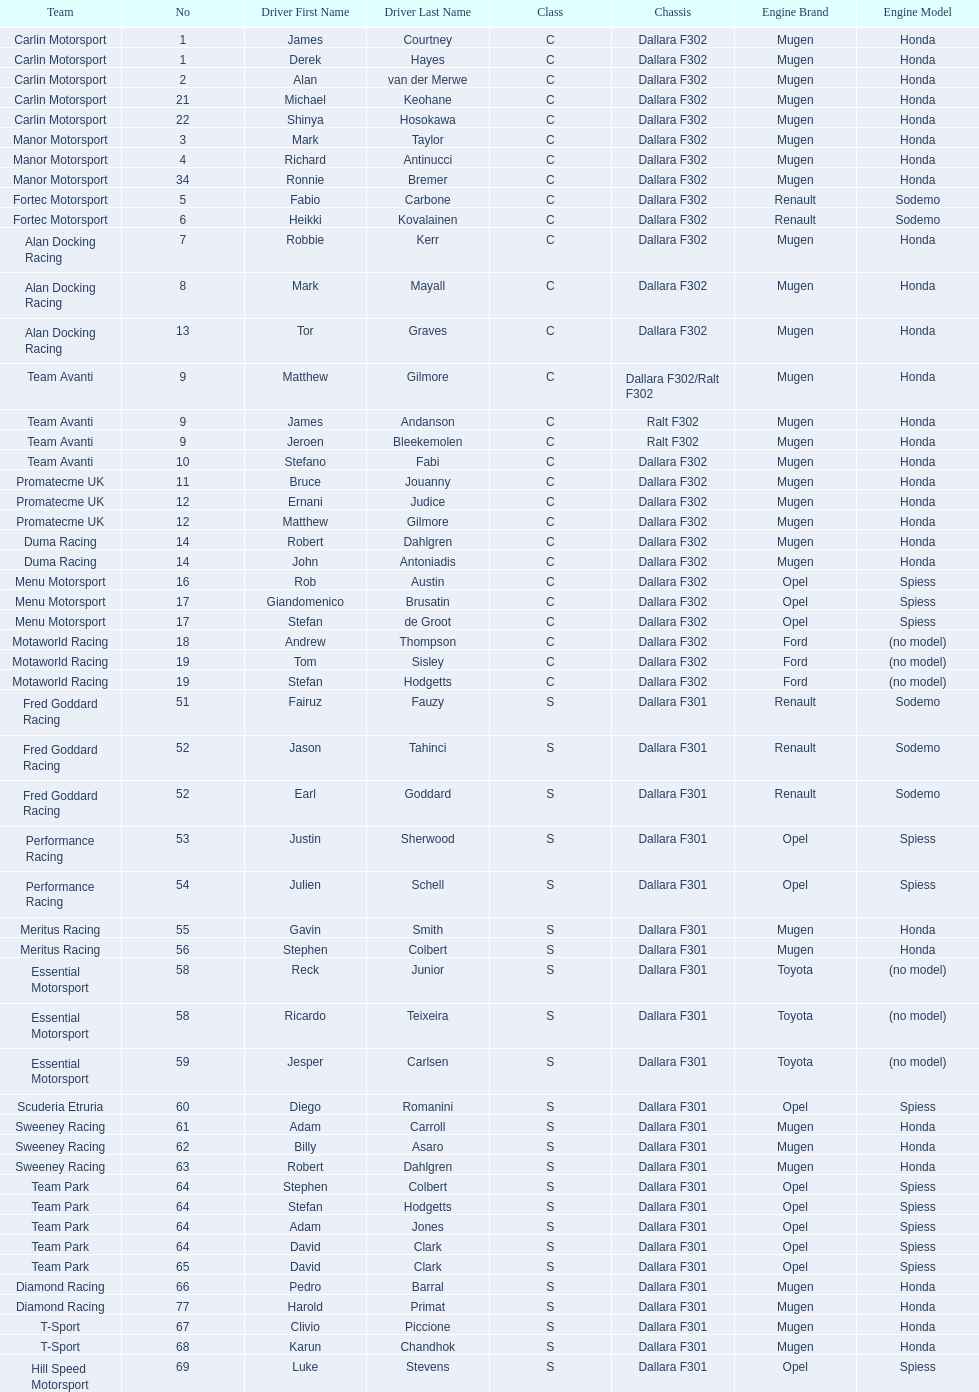Who had more drivers, team avanti or motaworld racing? Team Avanti. 